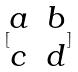<formula> <loc_0><loc_0><loc_500><loc_500>[ \begin{matrix} a & b \\ c & d \end{matrix} ]</formula> 